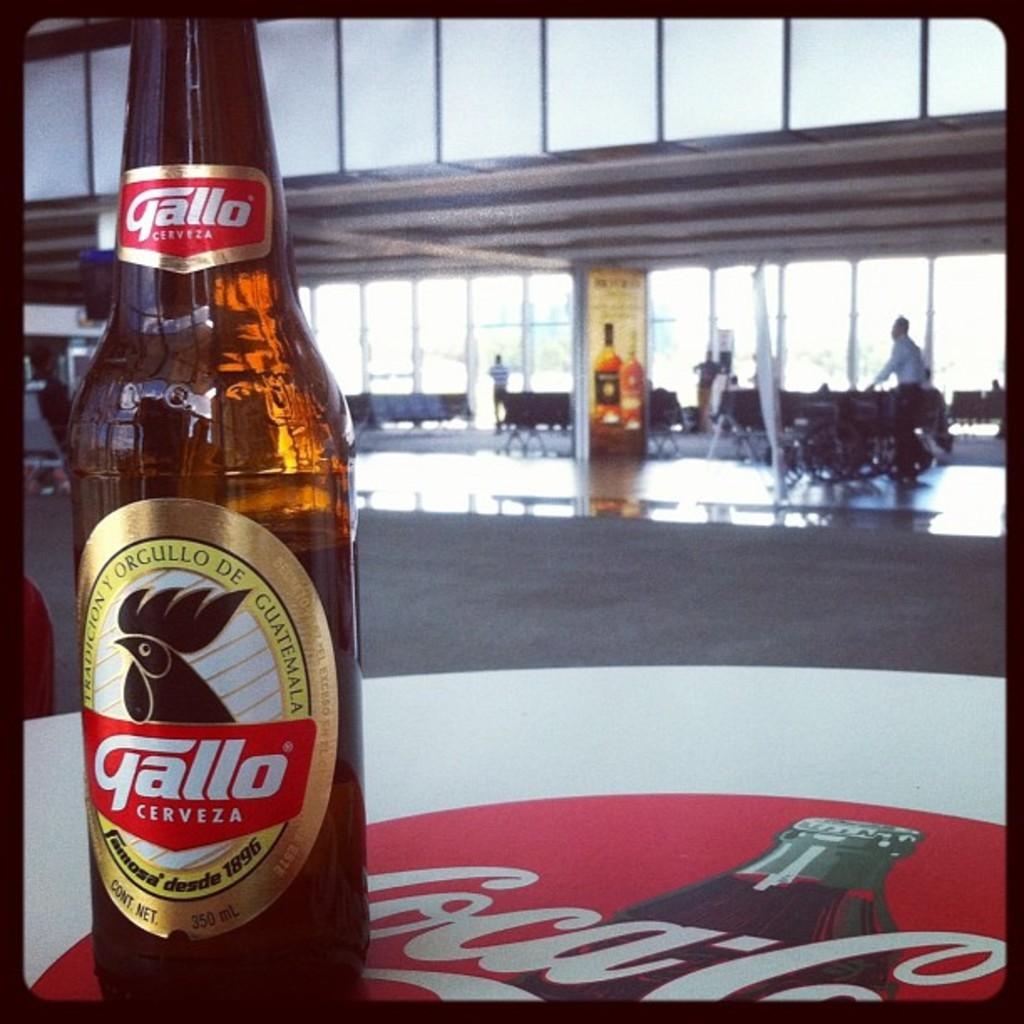Provide a one-sentence caption for the provided image. A bottle of Gallo Cerveza sits on a table brande by Coka Cola. 